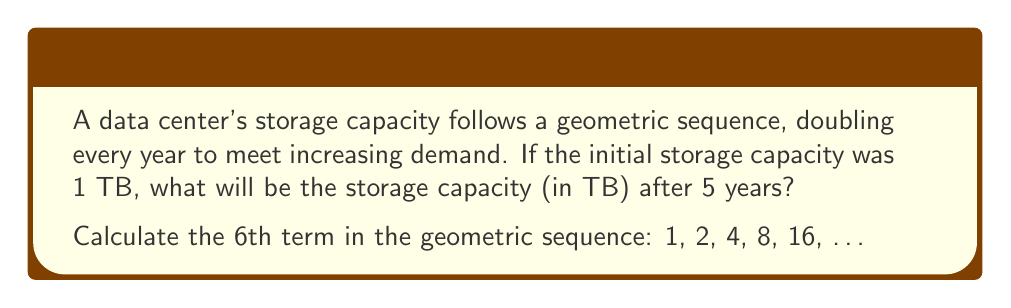Can you answer this question? To solve this problem, we'll follow these steps:

1. Identify the components of the geometric sequence:
   - First term: $a_1 = 1$ TB
   - Common ratio: $r = 2$ (doubles every year)

2. Use the geometric sequence formula:
   $a_n = a_1 \cdot r^{n-1}$
   Where:
   $a_n$ is the nth term
   $a_1$ is the first term
   $r$ is the common ratio
   $n$ is the term number

3. We want the 6th term (after 5 years), so $n = 6$:
   $a_6 = 1 \cdot 2^{6-1}$

4. Simplify:
   $a_6 = 1 \cdot 2^5$

5. Calculate:
   $a_6 = 1 \cdot 32 = 32$

Therefore, the storage capacity after 5 years (6th term) will be 32 TB.
Answer: 32 TB 